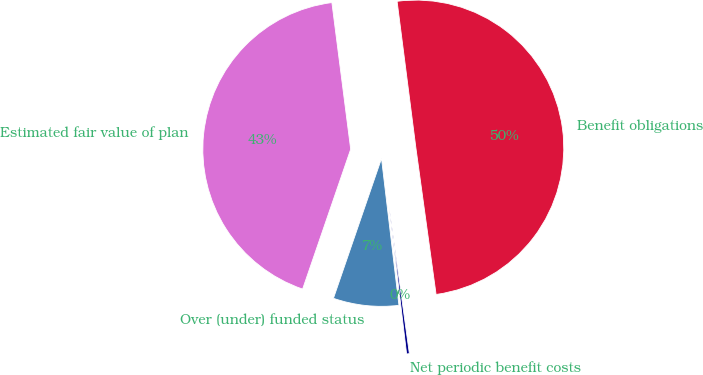<chart> <loc_0><loc_0><loc_500><loc_500><pie_chart><fcel>Benefit obligations<fcel>Estimated fair value of plan<fcel>Over (under) funded status<fcel>Net periodic benefit costs<nl><fcel>49.85%<fcel>42.7%<fcel>7.15%<fcel>0.3%<nl></chart> 